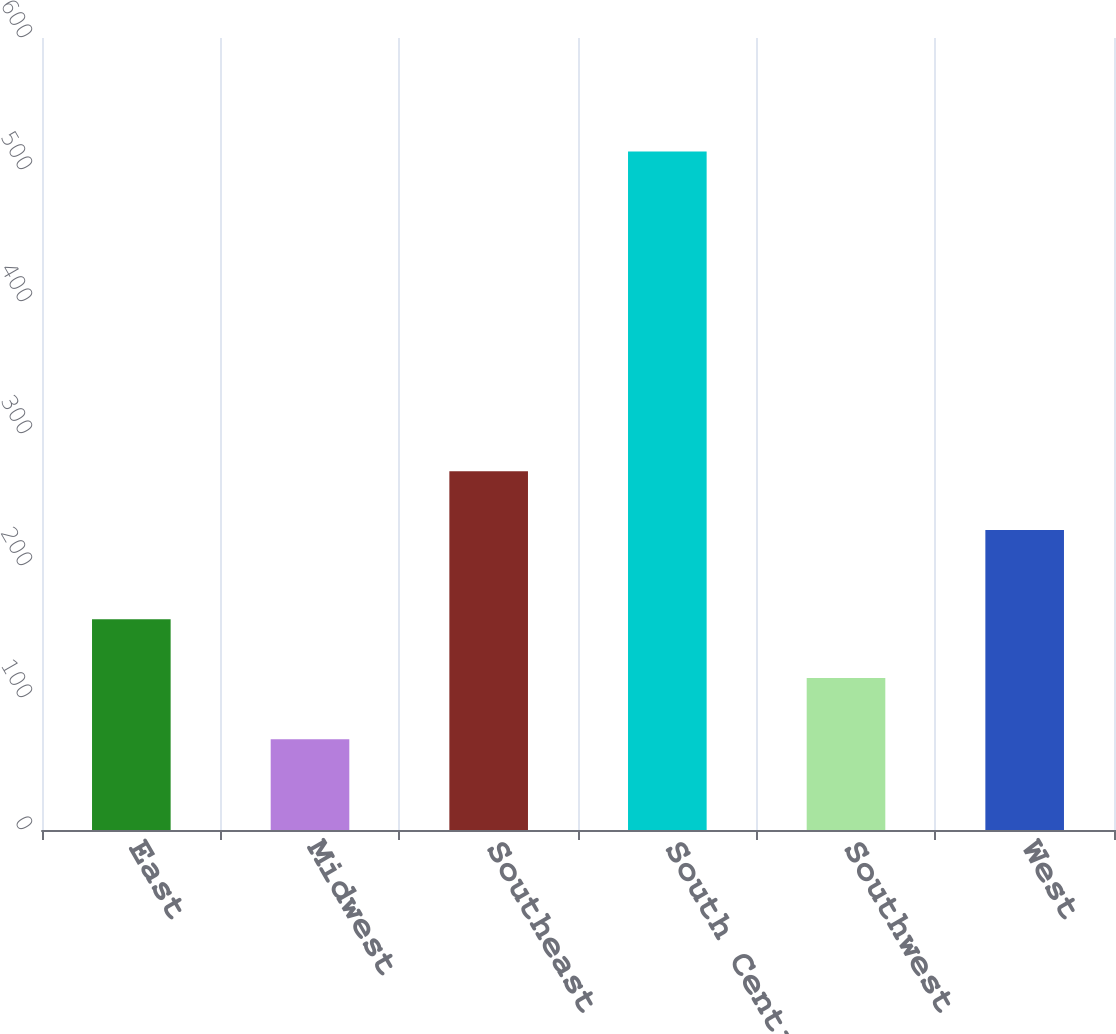Convert chart. <chart><loc_0><loc_0><loc_500><loc_500><bar_chart><fcel>East<fcel>Midwest<fcel>Southeast<fcel>South Central<fcel>Southwest<fcel>West<nl><fcel>159.64<fcel>68.7<fcel>271.84<fcel>514.1<fcel>115.1<fcel>227.3<nl></chart> 